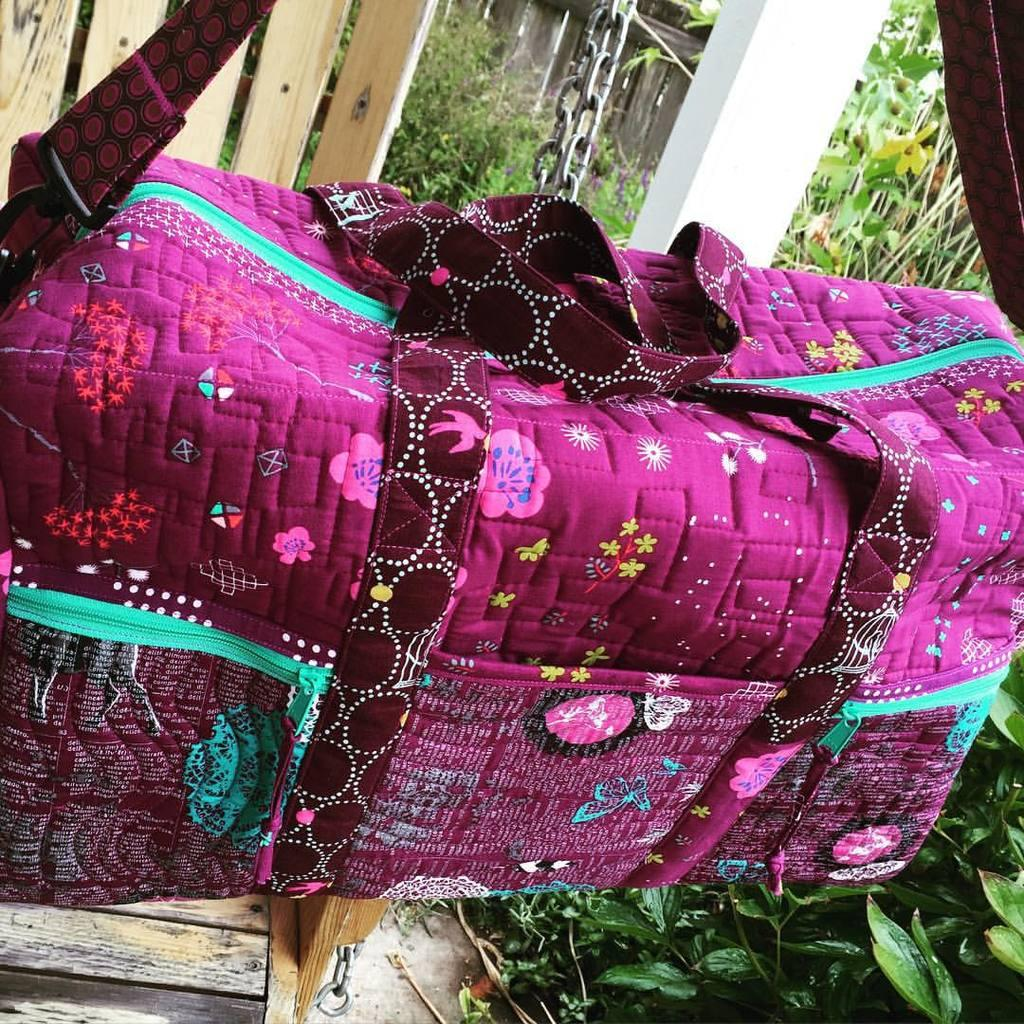What type of handbag is visible in the image? There is a pink handbag in the image. What design is featured on the handbag? The handbag has flowers printed on it. What type of vegetation can be seen in the area? There are plants and trees in the area. What type of carriage is used to transport the handbag in the image? There is no carriage present in the image, and the handbag is not being transported. 